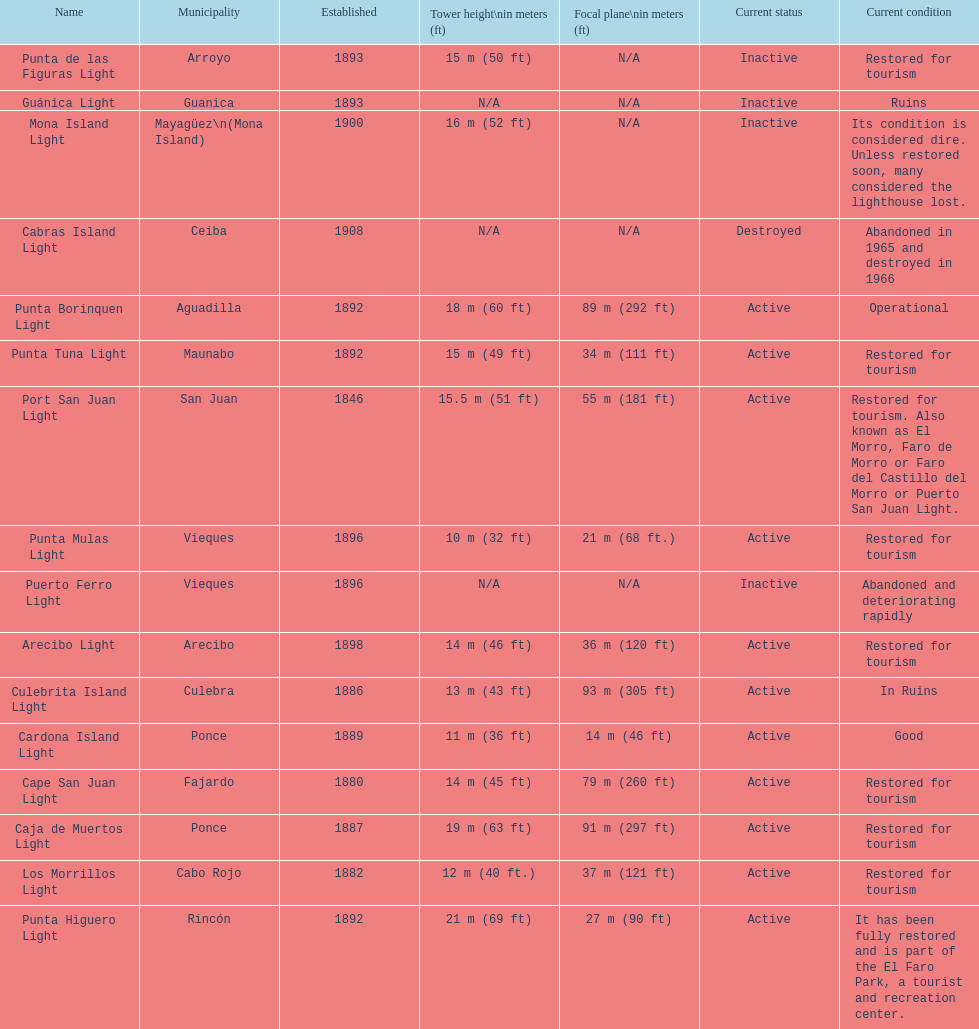Were any towers established before the year 1800? No. 